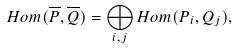Convert formula to latex. <formula><loc_0><loc_0><loc_500><loc_500>H o m ( \overline { P } , \overline { Q } ) = \bigoplus _ { i , j } H o m ( P _ { i } , Q _ { j } ) ,</formula> 